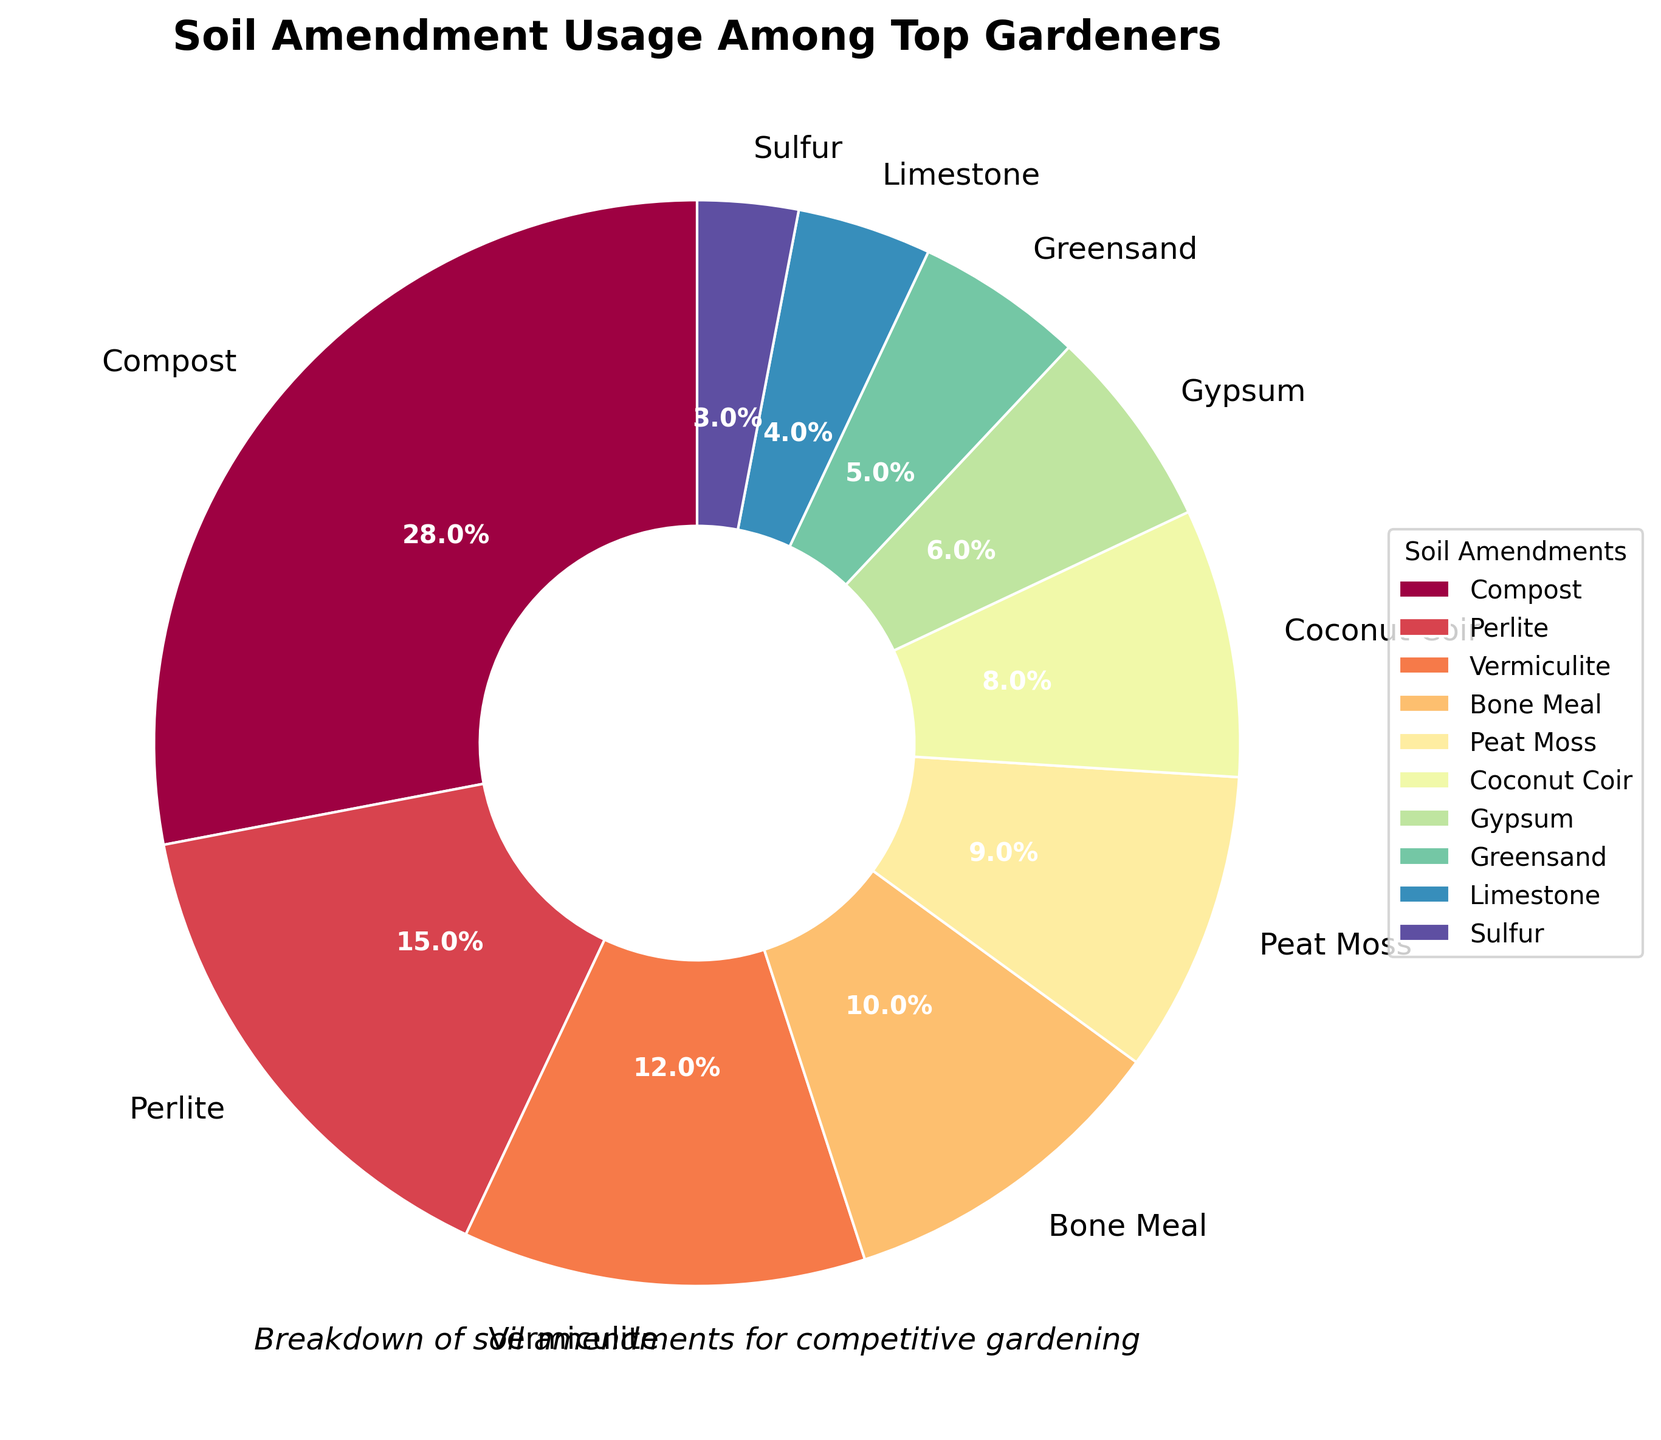Which soil amendment is used the most among top gardeners? The soil amendment with the highest percentage is the most used. From the chart, Compost has the highest percentage at 28%.
Answer: Compost What is the combined percentage of Perlite and Vermiculite usage? To find the combined percentage, add the percentages of Perlite (15%) and Vermiculite (12%). 15% + 12% = 27%.
Answer: 27% Which soil amendments have a usage percentage less than 10%? Look at the chart and identify all amendments with percentages lower than 10%. These are Peat Moss (9%), Coconut Coir (8%), Gypsum (6%), Greensand (5%), Limestone (4%), and Sulfur (3%).
Answer: Peat Moss, Coconut Coir, Gypsum, Greensand, Limestone, Sulfur How much lower is the percentage of Bone Meal compared to Vermiculite? Subtract the percentage of Bone Meal (10%) from Vermiculite (12%). 12% - 10% = 2%.
Answer: 2% What percentage of the total soil amendments do the least used amendments (Limestone and Sulfur) contribute? Add the percentages of Limestone (4%) and Sulfur (3%). 4% + 3% = 7%.
Answer: 7% Among the amendments shown, which two have the closest usage percentages? Compare the percentages of all amendments and identify the pair with the smallest difference. Perlite (15%) and Vermiculite (12%) have a difference of 3%, which is the smallest.
Answer: Perlite and Vermiculite What is the total percentage of usage of the three most used soil amendments? Add the percentages of the three most used amendments: Compost (28%), Perlite (15%), and Vermiculite (12%). 28% + 15% + 12% = 55%.
Answer: 55% Which soil amendment appears right before Peat Moss in the pie chart? Refer to the visual order of amendments in the pie chart and identify the one immediately before Peat Moss. Coconut Coir appears right before Peat Moss in the chart.
Answer: Coconut Coir What is the difference in usage percentage between Gypsum and Greensand? Subtract the percentage of Greensand (5%) from Gypsum (6%). 6% - 5% = 1%.
Answer: 1% 